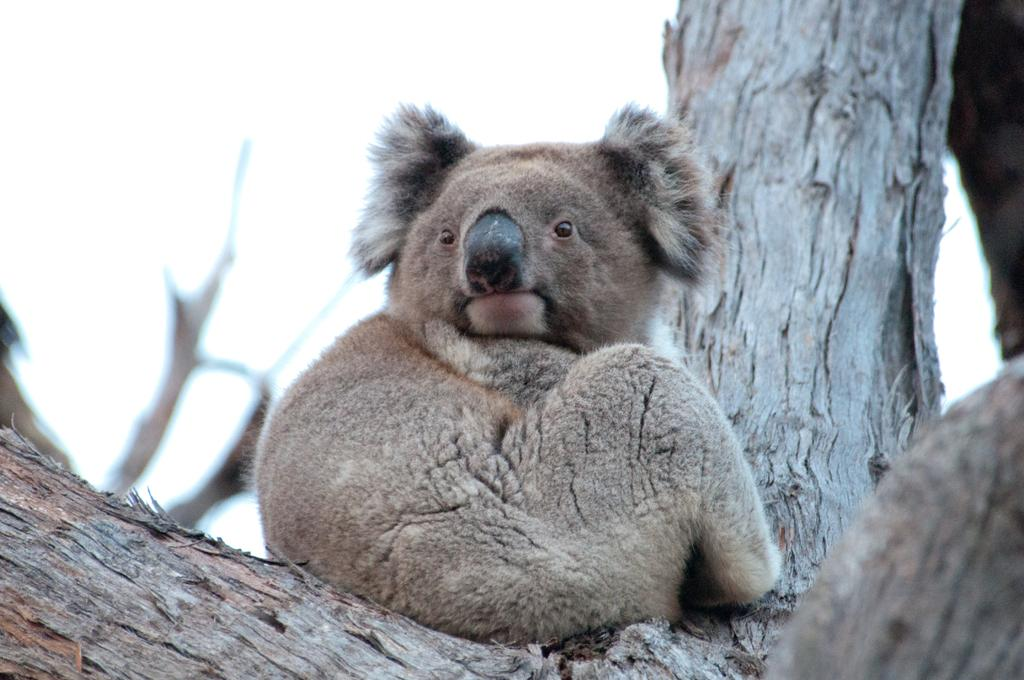What animal is in the image? There is a koala in the image. Where is the koala located? The koala is sitting on a tree. What is the condition of the sky in the image? The sky is clear in the image. What type of pump can be seen next to the koala in the image? There is no pump present in the image; it features a koala sitting on a tree with a clear sky. 